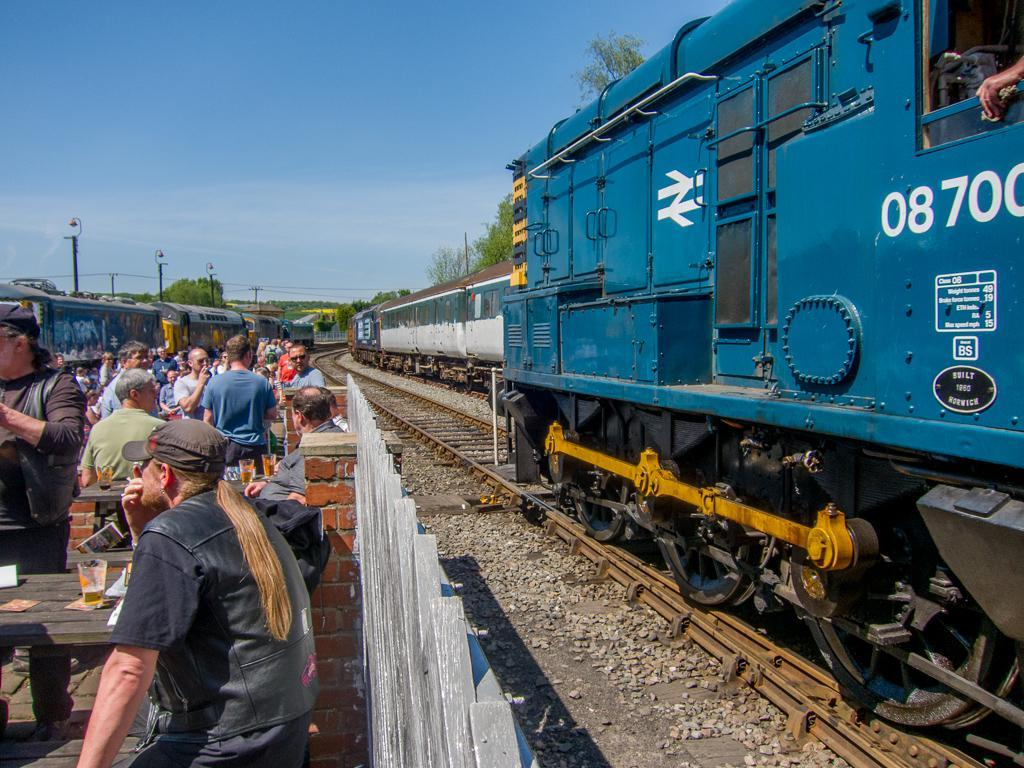Provide a one-sentence caption for the provided image. Blue locomotive number 08700 going by some bikers at a picnic table. 